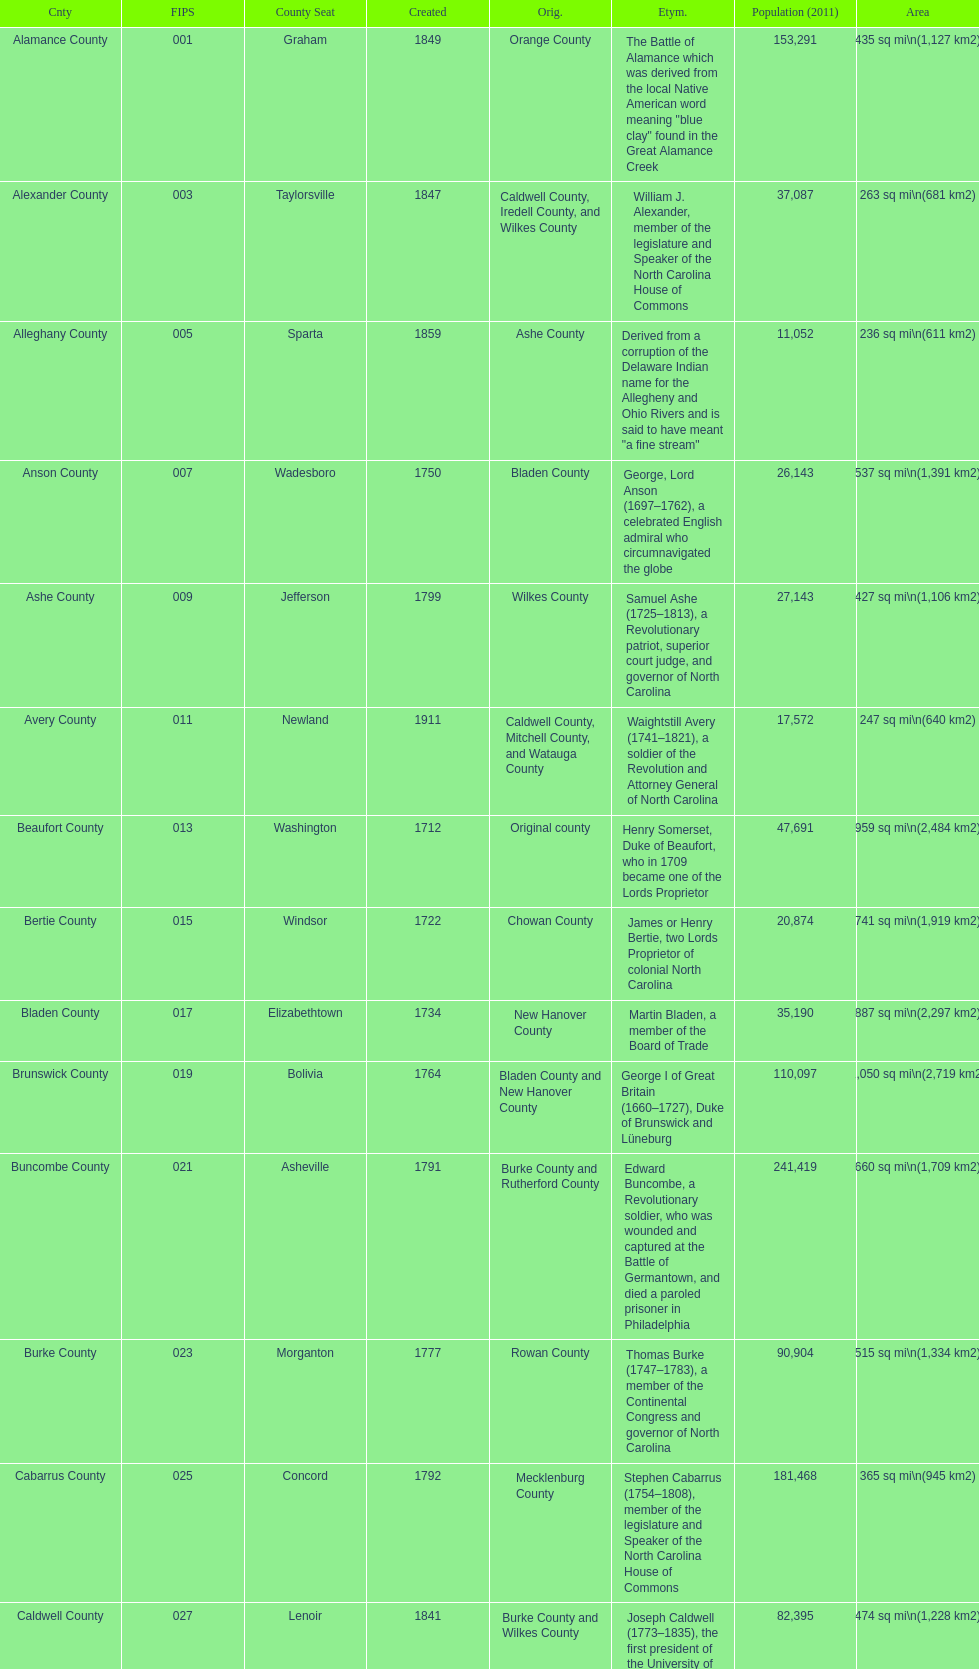What is the number of counties created in the 1800s? 37. 